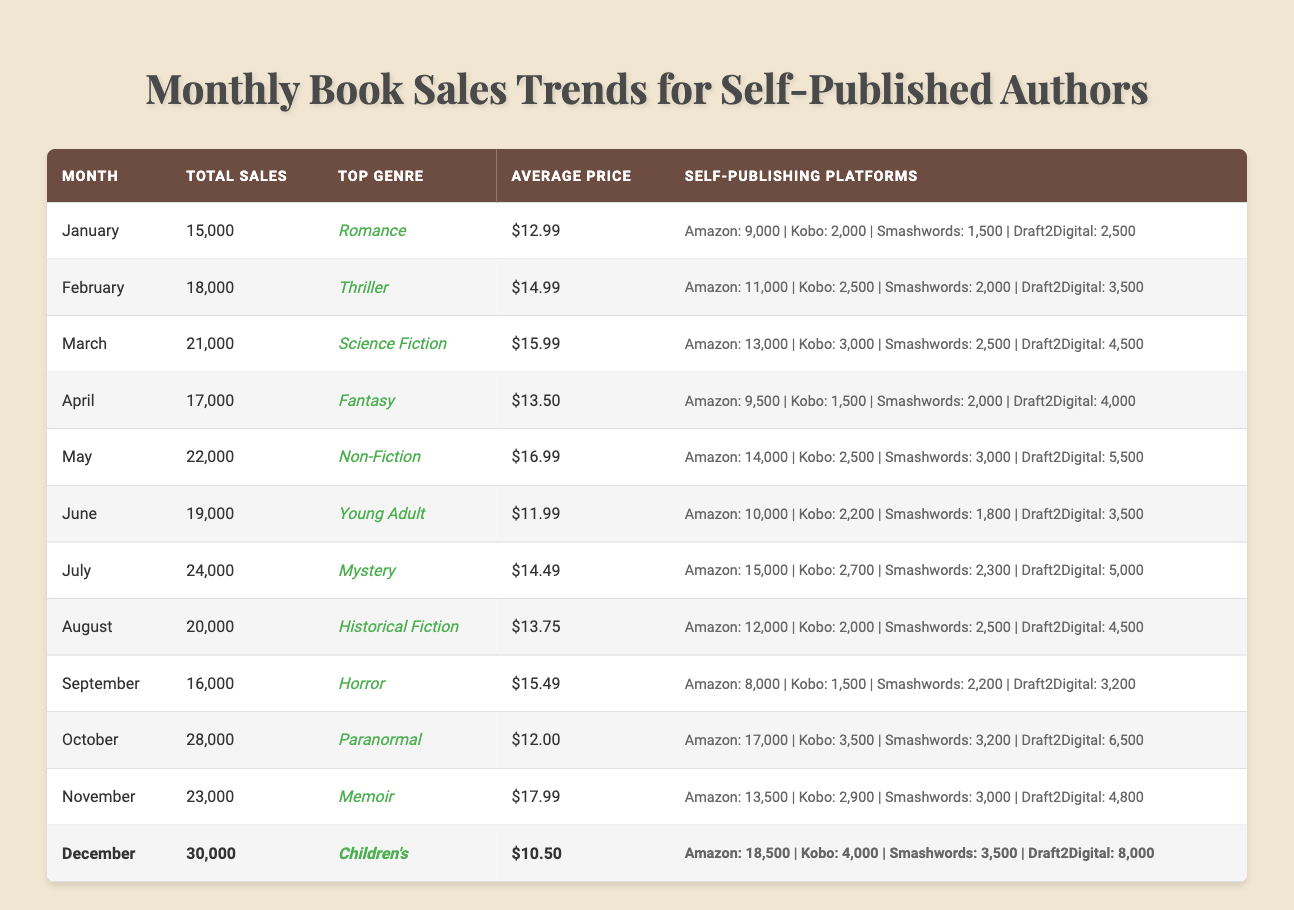What was the total sales in December? The table shows the total sales for December, which is listed as 30,000.
Answer: 30,000 What is the average price of books sold in April? In the April row of the table, the average price is marked as $13.50.
Answer: $13.50 Which genre had the highest sales in July? The table indicates that Mystery was the top genre for July, with total sales of 24,000.
Answer: Mystery How many total sales were made in the first half of the year (January to June)? We can sum the total sales from January (15,000), February (18,000), March (21,000), April (17,000), May (22,000), and June (19,000): 15,000 + 18,000 + 21,000 + 17,000 + 22,000 + 19,000 = 112,000.
Answer: 112,000 What percentage of total sales in August came from Amazon Kindle? In August, total sales were 20,000 and Amazon Kindle sales were 12,000. To find the percentage, we use the formula (Amazon sales / Total sales) * 100 = (12,000 / 20,000) * 100 = 60%.
Answer: 60% Was the top genre in March more popular than the top genre in September? March had Science Fiction as the top genre with 21,000 sales, while September had Horror with 16,000 sales. Since 21,000 is greater than 16,000, Science Fiction was more popular than Horror.
Answer: Yes How many total sales were there from all platforms combined in October? The total sales for October is explicitly stated as 28,000 in the table, which is equivalent to the sum of all sales from the platforms.
Answer: 28,000 Which month experienced the highest average price? By examining the average price column, we see that November had an average price of $17.99, which is the highest among all months.
Answer: November What is the difference in total sales between May and July? The total sales in May were 22,000, and in July, it was 24,000. The difference is calculated as 24,000 - 22,000 = 2,000.
Answer: 2,000 What was the trend for total sales from January to December? Observing the total sales from January (15,000) to December (30,000), we see a general increasing trend, peaking in December.
Answer: Increasing trend 